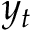Convert formula to latex. <formula><loc_0><loc_0><loc_500><loc_500>y _ { t }</formula> 